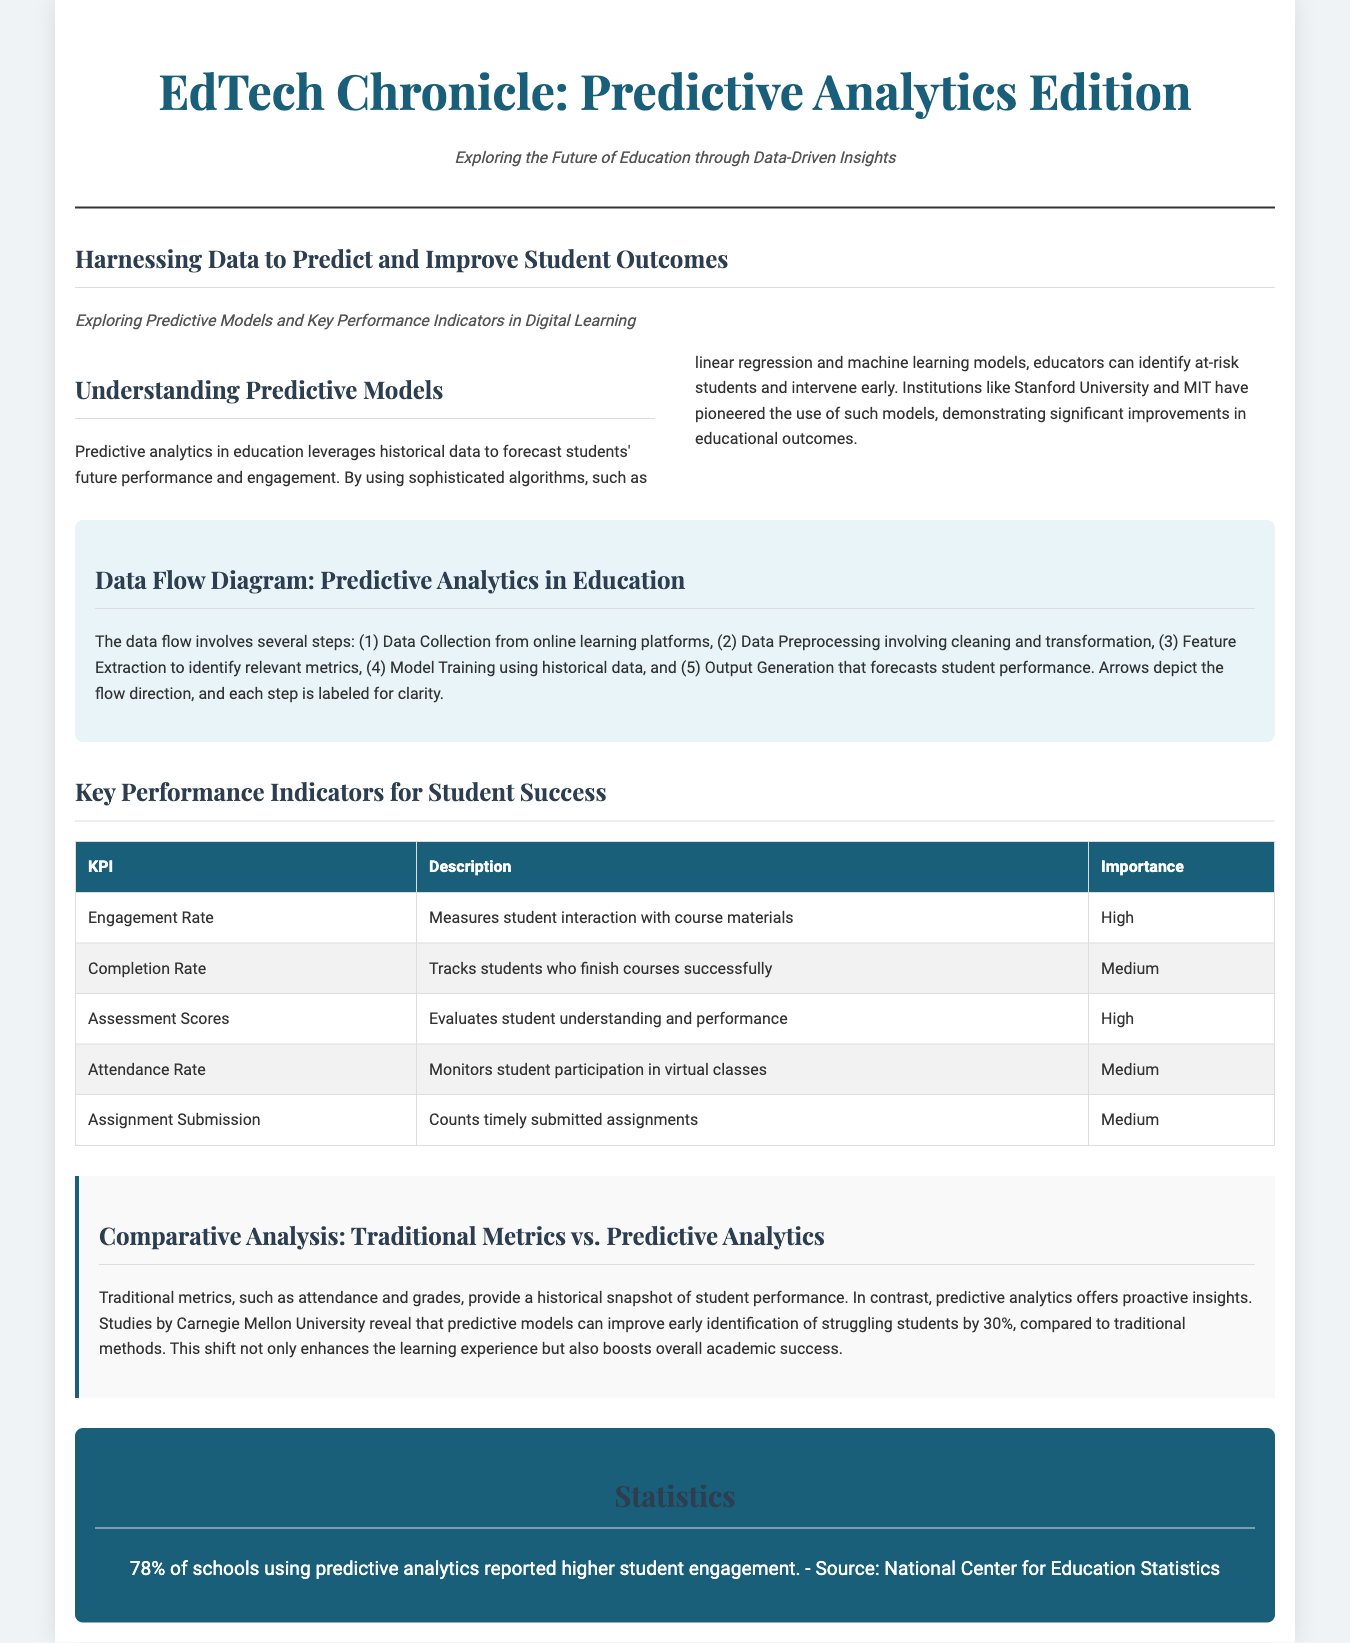What is the title of the document? The title can be found in the header section, which is "EdTech Chronicle: Predictive Analytics Edition."
Answer: EdTech Chronicle: Predictive Analytics Edition What is one of the algorithms mentioned for predictive models? The document states that algorithms such as linear regression and machine learning models are utilized for predictive analytics.
Answer: linear regression What is the importance level of the Engagement Rate KPI? The table specifies the importance level for the Engagement Rate as "High."
Answer: High What percentage of schools reported higher student engagement using predictive analytics? The document highlights that 78% of schools using predictive analytics reported higher student engagement.
Answer: 78% How many steps are involved in the data flow for predictive analytics? The document outlines a total of five steps in the data flow involved in predictive analytics in education.
Answer: 5 Which university is mentioned as a pioneer in using predictive models? The feature article mentions Stanford University and MIT as pioneering institutions in the use of predictive models.
Answer: Stanford University What type of metrics does predictive analytics provide compared to traditional methods? The document notes that predictive analytics offers proactive insights, contrasting with traditional metrics that provide a historical snapshot.
Answer: proactive insights What does the Comparative Analysis highlight regarding predictive models? The comparative analysis states that predictive models can improve early identification of struggling students by 30%, compared to traditional methods.
Answer: 30% What is the background color of the comparative analysis section? The comparative analysis section is described as having a background color of light gray (#f9f9f9).
Answer: light gray 